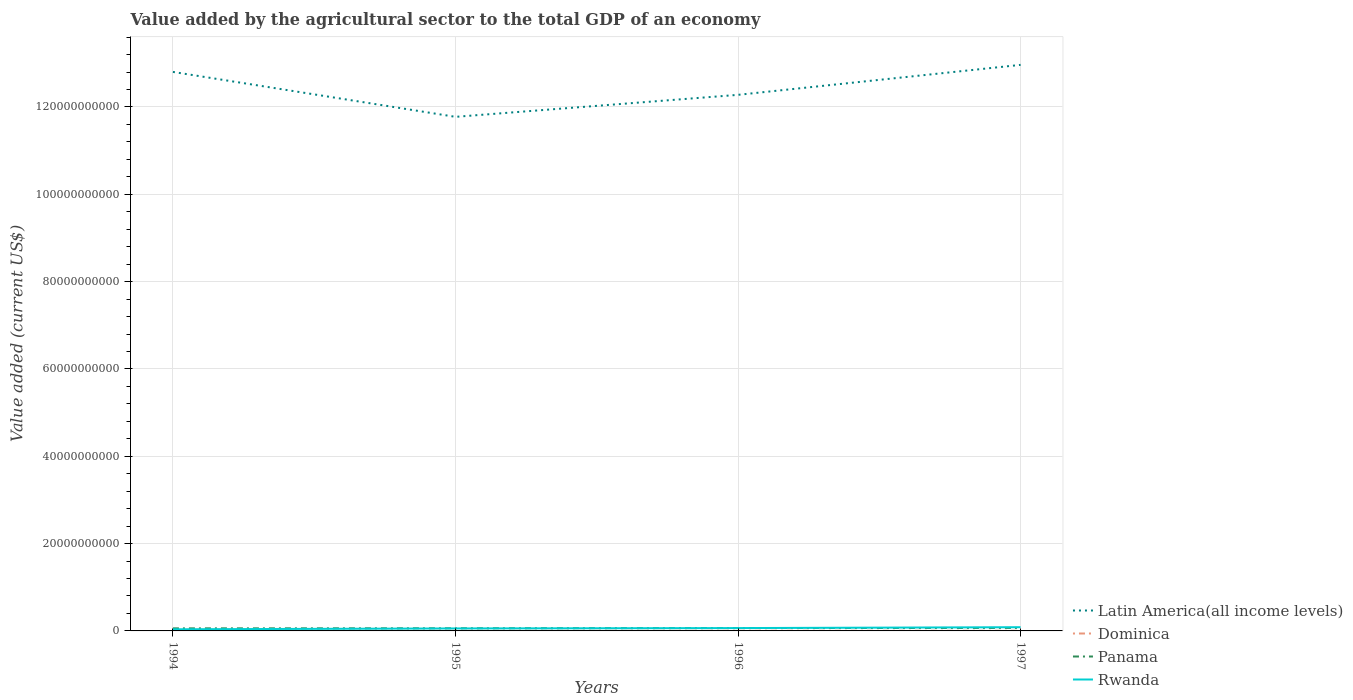Across all years, what is the maximum value added by the agricultural sector to the total GDP in Rwanda?
Your answer should be very brief. 3.75e+08. What is the total value added by the agricultural sector to the total GDP in Dominica in the graph?
Ensure brevity in your answer.  -4.83e+06. What is the difference between the highest and the second highest value added by the agricultural sector to the total GDP in Rwanda?
Offer a terse response. 4.76e+08. What is the difference between the highest and the lowest value added by the agricultural sector to the total GDP in Panama?
Offer a terse response. 2. How many years are there in the graph?
Your answer should be compact. 4. Does the graph contain grids?
Your answer should be compact. Yes. How many legend labels are there?
Give a very brief answer. 4. How are the legend labels stacked?
Your answer should be compact. Vertical. What is the title of the graph?
Make the answer very short. Value added by the agricultural sector to the total GDP of an economy. What is the label or title of the X-axis?
Your answer should be compact. Years. What is the label or title of the Y-axis?
Provide a short and direct response. Value added (current US$). What is the Value added (current US$) of Latin America(all income levels) in 1994?
Your answer should be compact. 1.28e+11. What is the Value added (current US$) in Dominica in 1994?
Make the answer very short. 3.98e+07. What is the Value added (current US$) in Panama in 1994?
Keep it short and to the point. 5.87e+08. What is the Value added (current US$) of Rwanda in 1994?
Provide a short and direct response. 3.75e+08. What is the Value added (current US$) in Latin America(all income levels) in 1995?
Provide a succinct answer. 1.18e+11. What is the Value added (current US$) of Dominica in 1995?
Your answer should be compact. 3.50e+07. What is the Value added (current US$) in Panama in 1995?
Your answer should be very brief. 6.02e+08. What is the Value added (current US$) of Rwanda in 1995?
Your answer should be very brief. 5.69e+08. What is the Value added (current US$) of Latin America(all income levels) in 1996?
Provide a short and direct response. 1.23e+11. What is the Value added (current US$) in Dominica in 1996?
Give a very brief answer. 3.96e+07. What is the Value added (current US$) of Panama in 1996?
Offer a terse response. 6.49e+08. What is the Value added (current US$) in Rwanda in 1996?
Provide a succinct answer. 6.52e+08. What is the Value added (current US$) of Latin America(all income levels) in 1997?
Your answer should be compact. 1.30e+11. What is the Value added (current US$) of Dominica in 1997?
Provide a short and direct response. 3.98e+07. What is the Value added (current US$) of Panama in 1997?
Keep it short and to the point. 6.89e+08. What is the Value added (current US$) in Rwanda in 1997?
Ensure brevity in your answer.  8.51e+08. Across all years, what is the maximum Value added (current US$) of Latin America(all income levels)?
Keep it short and to the point. 1.30e+11. Across all years, what is the maximum Value added (current US$) in Dominica?
Offer a very short reply. 3.98e+07. Across all years, what is the maximum Value added (current US$) in Panama?
Ensure brevity in your answer.  6.89e+08. Across all years, what is the maximum Value added (current US$) in Rwanda?
Your answer should be very brief. 8.51e+08. Across all years, what is the minimum Value added (current US$) of Latin America(all income levels)?
Keep it short and to the point. 1.18e+11. Across all years, what is the minimum Value added (current US$) of Dominica?
Your answer should be compact. 3.50e+07. Across all years, what is the minimum Value added (current US$) of Panama?
Give a very brief answer. 5.87e+08. Across all years, what is the minimum Value added (current US$) of Rwanda?
Keep it short and to the point. 3.75e+08. What is the total Value added (current US$) of Latin America(all income levels) in the graph?
Provide a short and direct response. 4.98e+11. What is the total Value added (current US$) of Dominica in the graph?
Give a very brief answer. 1.54e+08. What is the total Value added (current US$) in Panama in the graph?
Provide a short and direct response. 2.53e+09. What is the total Value added (current US$) in Rwanda in the graph?
Provide a succinct answer. 2.45e+09. What is the difference between the Value added (current US$) in Latin America(all income levels) in 1994 and that in 1995?
Give a very brief answer. 1.03e+1. What is the difference between the Value added (current US$) of Dominica in 1994 and that in 1995?
Your answer should be very brief. 4.74e+06. What is the difference between the Value added (current US$) in Panama in 1994 and that in 1995?
Your answer should be compact. -1.54e+07. What is the difference between the Value added (current US$) of Rwanda in 1994 and that in 1995?
Keep it short and to the point. -1.94e+08. What is the difference between the Value added (current US$) of Latin America(all income levels) in 1994 and that in 1996?
Your response must be concise. 5.25e+09. What is the difference between the Value added (current US$) in Dominica in 1994 and that in 1996?
Make the answer very short. 1.30e+05. What is the difference between the Value added (current US$) in Panama in 1994 and that in 1996?
Your response must be concise. -6.23e+07. What is the difference between the Value added (current US$) of Rwanda in 1994 and that in 1996?
Your response must be concise. -2.77e+08. What is the difference between the Value added (current US$) of Latin America(all income levels) in 1994 and that in 1997?
Provide a short and direct response. -1.61e+09. What is the difference between the Value added (current US$) of Dominica in 1994 and that in 1997?
Give a very brief answer. -8.89e+04. What is the difference between the Value added (current US$) in Panama in 1994 and that in 1997?
Keep it short and to the point. -1.02e+08. What is the difference between the Value added (current US$) in Rwanda in 1994 and that in 1997?
Your answer should be very brief. -4.76e+08. What is the difference between the Value added (current US$) of Latin America(all income levels) in 1995 and that in 1996?
Provide a succinct answer. -5.04e+09. What is the difference between the Value added (current US$) of Dominica in 1995 and that in 1996?
Your response must be concise. -4.61e+06. What is the difference between the Value added (current US$) in Panama in 1995 and that in 1996?
Ensure brevity in your answer.  -4.69e+07. What is the difference between the Value added (current US$) of Rwanda in 1995 and that in 1996?
Make the answer very short. -8.32e+07. What is the difference between the Value added (current US$) in Latin America(all income levels) in 1995 and that in 1997?
Provide a succinct answer. -1.19e+1. What is the difference between the Value added (current US$) of Dominica in 1995 and that in 1997?
Ensure brevity in your answer.  -4.83e+06. What is the difference between the Value added (current US$) in Panama in 1995 and that in 1997?
Offer a terse response. -8.69e+07. What is the difference between the Value added (current US$) of Rwanda in 1995 and that in 1997?
Ensure brevity in your answer.  -2.82e+08. What is the difference between the Value added (current US$) in Latin America(all income levels) in 1996 and that in 1997?
Give a very brief answer. -6.86e+09. What is the difference between the Value added (current US$) in Dominica in 1996 and that in 1997?
Your answer should be very brief. -2.19e+05. What is the difference between the Value added (current US$) of Panama in 1996 and that in 1997?
Offer a terse response. -4.00e+07. What is the difference between the Value added (current US$) in Rwanda in 1996 and that in 1997?
Ensure brevity in your answer.  -1.99e+08. What is the difference between the Value added (current US$) of Latin America(all income levels) in 1994 and the Value added (current US$) of Dominica in 1995?
Your response must be concise. 1.28e+11. What is the difference between the Value added (current US$) of Latin America(all income levels) in 1994 and the Value added (current US$) of Panama in 1995?
Provide a succinct answer. 1.27e+11. What is the difference between the Value added (current US$) of Latin America(all income levels) in 1994 and the Value added (current US$) of Rwanda in 1995?
Provide a short and direct response. 1.27e+11. What is the difference between the Value added (current US$) in Dominica in 1994 and the Value added (current US$) in Panama in 1995?
Provide a short and direct response. -5.62e+08. What is the difference between the Value added (current US$) of Dominica in 1994 and the Value added (current US$) of Rwanda in 1995?
Make the answer very short. -5.29e+08. What is the difference between the Value added (current US$) in Panama in 1994 and the Value added (current US$) in Rwanda in 1995?
Give a very brief answer. 1.76e+07. What is the difference between the Value added (current US$) in Latin America(all income levels) in 1994 and the Value added (current US$) in Dominica in 1996?
Offer a terse response. 1.28e+11. What is the difference between the Value added (current US$) of Latin America(all income levels) in 1994 and the Value added (current US$) of Panama in 1996?
Your answer should be very brief. 1.27e+11. What is the difference between the Value added (current US$) in Latin America(all income levels) in 1994 and the Value added (current US$) in Rwanda in 1996?
Provide a succinct answer. 1.27e+11. What is the difference between the Value added (current US$) in Dominica in 1994 and the Value added (current US$) in Panama in 1996?
Your answer should be very brief. -6.09e+08. What is the difference between the Value added (current US$) in Dominica in 1994 and the Value added (current US$) in Rwanda in 1996?
Offer a very short reply. -6.13e+08. What is the difference between the Value added (current US$) of Panama in 1994 and the Value added (current US$) of Rwanda in 1996?
Make the answer very short. -6.55e+07. What is the difference between the Value added (current US$) of Latin America(all income levels) in 1994 and the Value added (current US$) of Dominica in 1997?
Ensure brevity in your answer.  1.28e+11. What is the difference between the Value added (current US$) in Latin America(all income levels) in 1994 and the Value added (current US$) in Panama in 1997?
Give a very brief answer. 1.27e+11. What is the difference between the Value added (current US$) in Latin America(all income levels) in 1994 and the Value added (current US$) in Rwanda in 1997?
Make the answer very short. 1.27e+11. What is the difference between the Value added (current US$) in Dominica in 1994 and the Value added (current US$) in Panama in 1997?
Your answer should be compact. -6.49e+08. What is the difference between the Value added (current US$) of Dominica in 1994 and the Value added (current US$) of Rwanda in 1997?
Your answer should be compact. -8.11e+08. What is the difference between the Value added (current US$) of Panama in 1994 and the Value added (current US$) of Rwanda in 1997?
Provide a short and direct response. -2.64e+08. What is the difference between the Value added (current US$) in Latin America(all income levels) in 1995 and the Value added (current US$) in Dominica in 1996?
Provide a succinct answer. 1.18e+11. What is the difference between the Value added (current US$) in Latin America(all income levels) in 1995 and the Value added (current US$) in Panama in 1996?
Ensure brevity in your answer.  1.17e+11. What is the difference between the Value added (current US$) of Latin America(all income levels) in 1995 and the Value added (current US$) of Rwanda in 1996?
Your response must be concise. 1.17e+11. What is the difference between the Value added (current US$) of Dominica in 1995 and the Value added (current US$) of Panama in 1996?
Give a very brief answer. -6.14e+08. What is the difference between the Value added (current US$) of Dominica in 1995 and the Value added (current US$) of Rwanda in 1996?
Offer a terse response. -6.17e+08. What is the difference between the Value added (current US$) in Panama in 1995 and the Value added (current US$) in Rwanda in 1996?
Provide a short and direct response. -5.01e+07. What is the difference between the Value added (current US$) in Latin America(all income levels) in 1995 and the Value added (current US$) in Dominica in 1997?
Offer a terse response. 1.18e+11. What is the difference between the Value added (current US$) of Latin America(all income levels) in 1995 and the Value added (current US$) of Panama in 1997?
Your answer should be compact. 1.17e+11. What is the difference between the Value added (current US$) in Latin America(all income levels) in 1995 and the Value added (current US$) in Rwanda in 1997?
Offer a terse response. 1.17e+11. What is the difference between the Value added (current US$) of Dominica in 1995 and the Value added (current US$) of Panama in 1997?
Offer a very short reply. -6.54e+08. What is the difference between the Value added (current US$) in Dominica in 1995 and the Value added (current US$) in Rwanda in 1997?
Offer a terse response. -8.16e+08. What is the difference between the Value added (current US$) in Panama in 1995 and the Value added (current US$) in Rwanda in 1997?
Your response must be concise. -2.49e+08. What is the difference between the Value added (current US$) in Latin America(all income levels) in 1996 and the Value added (current US$) in Dominica in 1997?
Make the answer very short. 1.23e+11. What is the difference between the Value added (current US$) in Latin America(all income levels) in 1996 and the Value added (current US$) in Panama in 1997?
Your answer should be very brief. 1.22e+11. What is the difference between the Value added (current US$) of Latin America(all income levels) in 1996 and the Value added (current US$) of Rwanda in 1997?
Keep it short and to the point. 1.22e+11. What is the difference between the Value added (current US$) of Dominica in 1996 and the Value added (current US$) of Panama in 1997?
Offer a very short reply. -6.49e+08. What is the difference between the Value added (current US$) in Dominica in 1996 and the Value added (current US$) in Rwanda in 1997?
Provide a short and direct response. -8.11e+08. What is the difference between the Value added (current US$) in Panama in 1996 and the Value added (current US$) in Rwanda in 1997?
Your answer should be very brief. -2.02e+08. What is the average Value added (current US$) of Latin America(all income levels) per year?
Your answer should be very brief. 1.25e+11. What is the average Value added (current US$) of Dominica per year?
Provide a succinct answer. 3.86e+07. What is the average Value added (current US$) of Panama per year?
Offer a terse response. 6.32e+08. What is the average Value added (current US$) in Rwanda per year?
Offer a terse response. 6.12e+08. In the year 1994, what is the difference between the Value added (current US$) in Latin America(all income levels) and Value added (current US$) in Dominica?
Your response must be concise. 1.28e+11. In the year 1994, what is the difference between the Value added (current US$) in Latin America(all income levels) and Value added (current US$) in Panama?
Ensure brevity in your answer.  1.27e+11. In the year 1994, what is the difference between the Value added (current US$) in Latin America(all income levels) and Value added (current US$) in Rwanda?
Give a very brief answer. 1.28e+11. In the year 1994, what is the difference between the Value added (current US$) in Dominica and Value added (current US$) in Panama?
Offer a very short reply. -5.47e+08. In the year 1994, what is the difference between the Value added (current US$) in Dominica and Value added (current US$) in Rwanda?
Offer a terse response. -3.35e+08. In the year 1994, what is the difference between the Value added (current US$) in Panama and Value added (current US$) in Rwanda?
Offer a terse response. 2.12e+08. In the year 1995, what is the difference between the Value added (current US$) of Latin America(all income levels) and Value added (current US$) of Dominica?
Offer a very short reply. 1.18e+11. In the year 1995, what is the difference between the Value added (current US$) in Latin America(all income levels) and Value added (current US$) in Panama?
Keep it short and to the point. 1.17e+11. In the year 1995, what is the difference between the Value added (current US$) of Latin America(all income levels) and Value added (current US$) of Rwanda?
Provide a succinct answer. 1.17e+11. In the year 1995, what is the difference between the Value added (current US$) in Dominica and Value added (current US$) in Panama?
Your answer should be very brief. -5.67e+08. In the year 1995, what is the difference between the Value added (current US$) in Dominica and Value added (current US$) in Rwanda?
Provide a short and direct response. -5.34e+08. In the year 1995, what is the difference between the Value added (current US$) in Panama and Value added (current US$) in Rwanda?
Provide a short and direct response. 3.30e+07. In the year 1996, what is the difference between the Value added (current US$) of Latin America(all income levels) and Value added (current US$) of Dominica?
Your response must be concise. 1.23e+11. In the year 1996, what is the difference between the Value added (current US$) in Latin America(all income levels) and Value added (current US$) in Panama?
Give a very brief answer. 1.22e+11. In the year 1996, what is the difference between the Value added (current US$) of Latin America(all income levels) and Value added (current US$) of Rwanda?
Provide a succinct answer. 1.22e+11. In the year 1996, what is the difference between the Value added (current US$) in Dominica and Value added (current US$) in Panama?
Your answer should be compact. -6.09e+08. In the year 1996, what is the difference between the Value added (current US$) in Dominica and Value added (current US$) in Rwanda?
Ensure brevity in your answer.  -6.13e+08. In the year 1996, what is the difference between the Value added (current US$) of Panama and Value added (current US$) of Rwanda?
Provide a short and direct response. -3.21e+06. In the year 1997, what is the difference between the Value added (current US$) in Latin America(all income levels) and Value added (current US$) in Dominica?
Offer a terse response. 1.30e+11. In the year 1997, what is the difference between the Value added (current US$) of Latin America(all income levels) and Value added (current US$) of Panama?
Give a very brief answer. 1.29e+11. In the year 1997, what is the difference between the Value added (current US$) in Latin America(all income levels) and Value added (current US$) in Rwanda?
Provide a succinct answer. 1.29e+11. In the year 1997, what is the difference between the Value added (current US$) of Dominica and Value added (current US$) of Panama?
Offer a terse response. -6.49e+08. In the year 1997, what is the difference between the Value added (current US$) of Dominica and Value added (current US$) of Rwanda?
Your answer should be very brief. -8.11e+08. In the year 1997, what is the difference between the Value added (current US$) in Panama and Value added (current US$) in Rwanda?
Your answer should be very brief. -1.62e+08. What is the ratio of the Value added (current US$) of Latin America(all income levels) in 1994 to that in 1995?
Give a very brief answer. 1.09. What is the ratio of the Value added (current US$) of Dominica in 1994 to that in 1995?
Your answer should be very brief. 1.14. What is the ratio of the Value added (current US$) of Panama in 1994 to that in 1995?
Make the answer very short. 0.97. What is the ratio of the Value added (current US$) of Rwanda in 1994 to that in 1995?
Your response must be concise. 0.66. What is the ratio of the Value added (current US$) in Latin America(all income levels) in 1994 to that in 1996?
Offer a terse response. 1.04. What is the ratio of the Value added (current US$) of Panama in 1994 to that in 1996?
Your answer should be very brief. 0.9. What is the ratio of the Value added (current US$) of Rwanda in 1994 to that in 1996?
Keep it short and to the point. 0.57. What is the ratio of the Value added (current US$) in Latin America(all income levels) in 1994 to that in 1997?
Make the answer very short. 0.99. What is the ratio of the Value added (current US$) of Dominica in 1994 to that in 1997?
Provide a succinct answer. 1. What is the ratio of the Value added (current US$) of Panama in 1994 to that in 1997?
Offer a very short reply. 0.85. What is the ratio of the Value added (current US$) of Rwanda in 1994 to that in 1997?
Ensure brevity in your answer.  0.44. What is the ratio of the Value added (current US$) of Latin America(all income levels) in 1995 to that in 1996?
Offer a very short reply. 0.96. What is the ratio of the Value added (current US$) of Dominica in 1995 to that in 1996?
Your answer should be very brief. 0.88. What is the ratio of the Value added (current US$) in Panama in 1995 to that in 1996?
Offer a terse response. 0.93. What is the ratio of the Value added (current US$) of Rwanda in 1995 to that in 1996?
Provide a short and direct response. 0.87. What is the ratio of the Value added (current US$) in Latin America(all income levels) in 1995 to that in 1997?
Your response must be concise. 0.91. What is the ratio of the Value added (current US$) in Dominica in 1995 to that in 1997?
Offer a terse response. 0.88. What is the ratio of the Value added (current US$) in Panama in 1995 to that in 1997?
Give a very brief answer. 0.87. What is the ratio of the Value added (current US$) of Rwanda in 1995 to that in 1997?
Make the answer very short. 0.67. What is the ratio of the Value added (current US$) in Latin America(all income levels) in 1996 to that in 1997?
Give a very brief answer. 0.95. What is the ratio of the Value added (current US$) of Dominica in 1996 to that in 1997?
Provide a succinct answer. 0.99. What is the ratio of the Value added (current US$) in Panama in 1996 to that in 1997?
Your answer should be very brief. 0.94. What is the ratio of the Value added (current US$) in Rwanda in 1996 to that in 1997?
Your answer should be compact. 0.77. What is the difference between the highest and the second highest Value added (current US$) of Latin America(all income levels)?
Give a very brief answer. 1.61e+09. What is the difference between the highest and the second highest Value added (current US$) of Dominica?
Your response must be concise. 8.89e+04. What is the difference between the highest and the second highest Value added (current US$) in Panama?
Your answer should be compact. 4.00e+07. What is the difference between the highest and the second highest Value added (current US$) in Rwanda?
Provide a short and direct response. 1.99e+08. What is the difference between the highest and the lowest Value added (current US$) of Latin America(all income levels)?
Offer a terse response. 1.19e+1. What is the difference between the highest and the lowest Value added (current US$) of Dominica?
Provide a succinct answer. 4.83e+06. What is the difference between the highest and the lowest Value added (current US$) of Panama?
Your answer should be compact. 1.02e+08. What is the difference between the highest and the lowest Value added (current US$) in Rwanda?
Provide a succinct answer. 4.76e+08. 